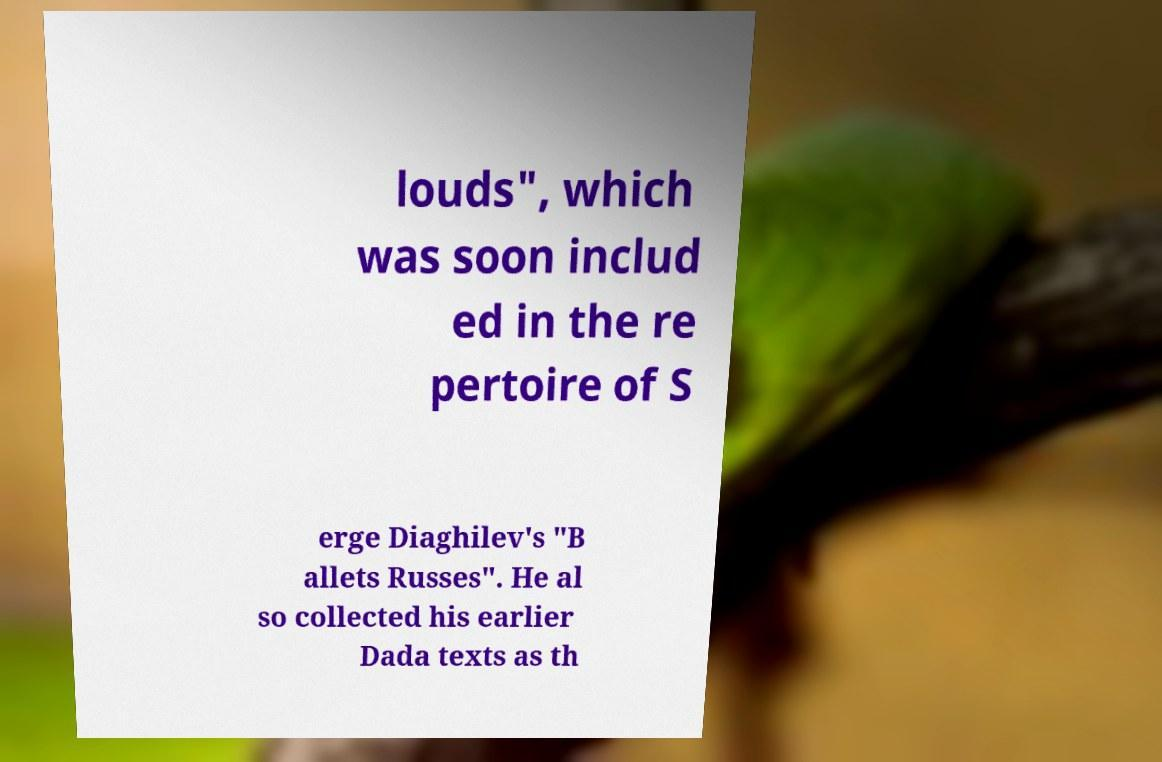Please read and relay the text visible in this image. What does it say? louds", which was soon includ ed in the re pertoire of S erge Diaghilev's "B allets Russes". He al so collected his earlier Dada texts as th 